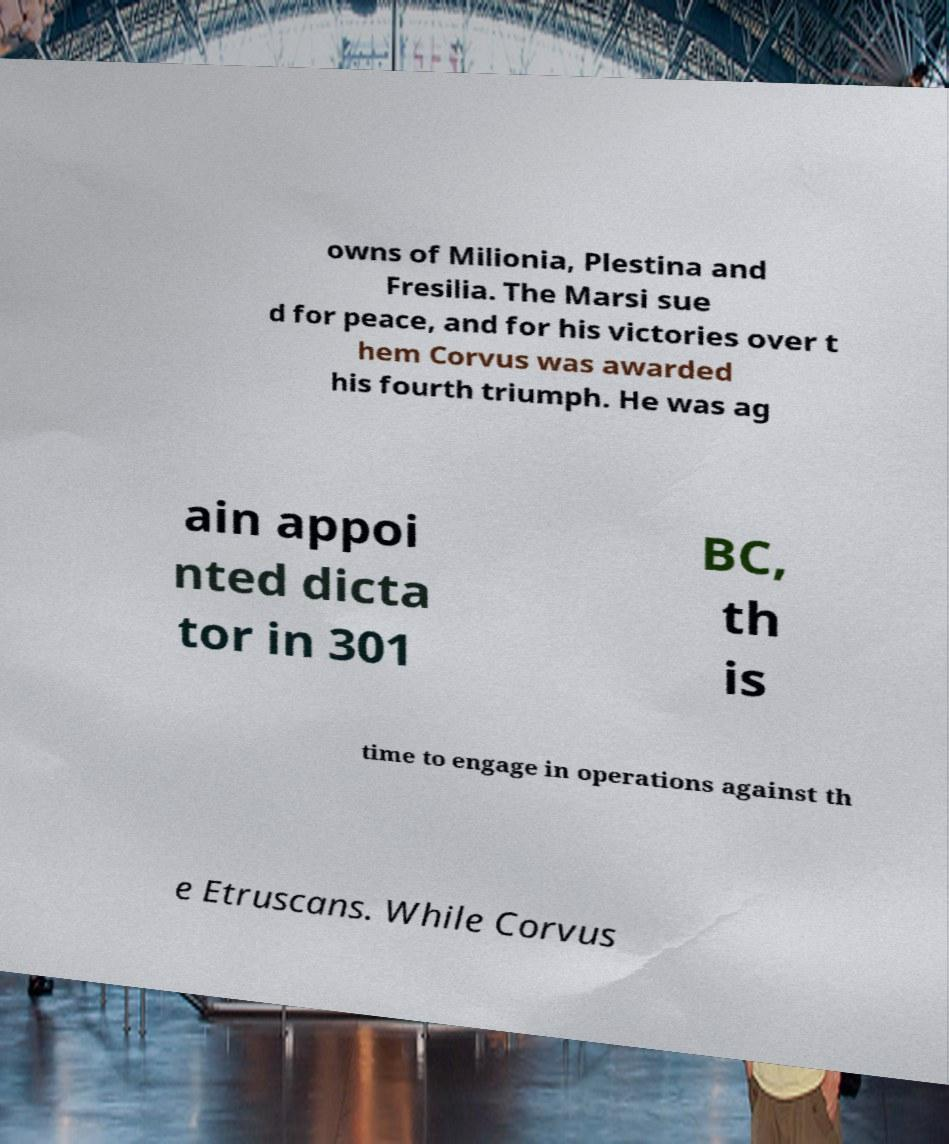Can you accurately transcribe the text from the provided image for me? owns of Milionia, Plestina and Fresilia. The Marsi sue d for peace, and for his victories over t hem Corvus was awarded his fourth triumph. He was ag ain appoi nted dicta tor in 301 BC, th is time to engage in operations against th e Etruscans. While Corvus 